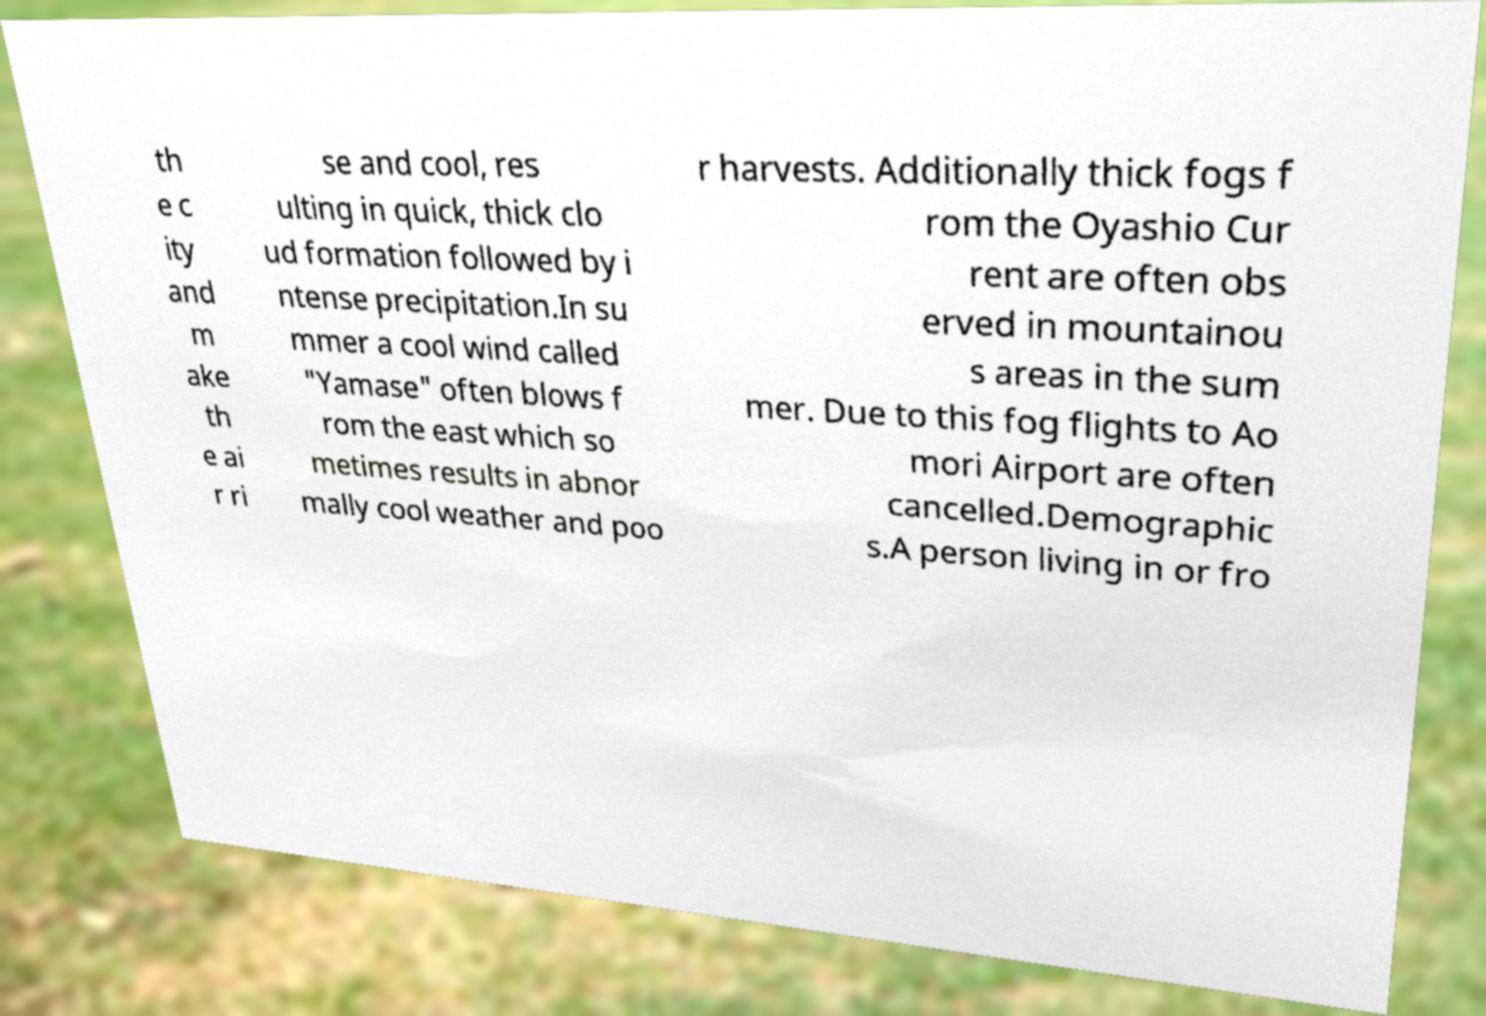Could you extract and type out the text from this image? th e c ity and m ake th e ai r ri se and cool, res ulting in quick, thick clo ud formation followed by i ntense precipitation.In su mmer a cool wind called "Yamase" often blows f rom the east which so metimes results in abnor mally cool weather and poo r harvests. Additionally thick fogs f rom the Oyashio Cur rent are often obs erved in mountainou s areas in the sum mer. Due to this fog flights to Ao mori Airport are often cancelled.Demographic s.A person living in or fro 